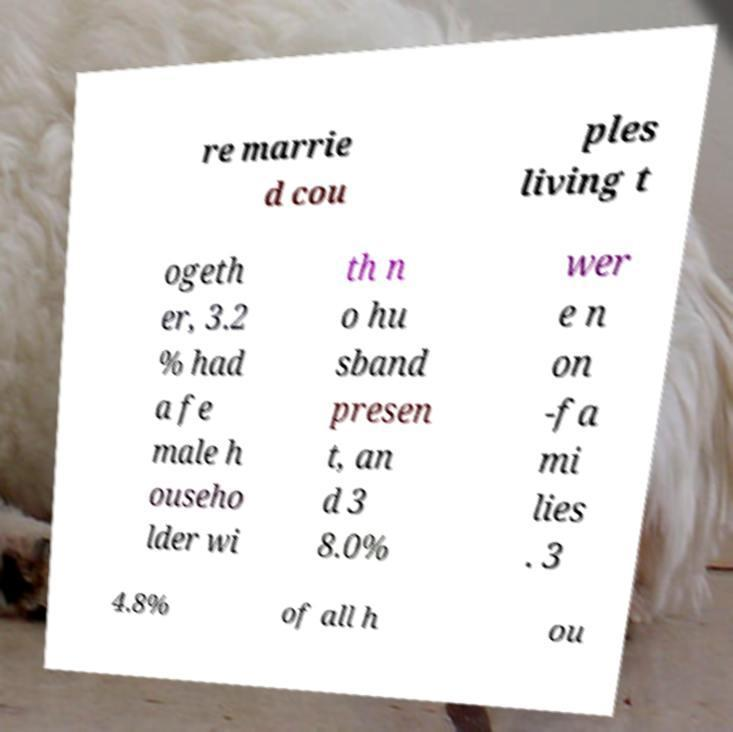For documentation purposes, I need the text within this image transcribed. Could you provide that? re marrie d cou ples living t ogeth er, 3.2 % had a fe male h ouseho lder wi th n o hu sband presen t, an d 3 8.0% wer e n on -fa mi lies . 3 4.8% of all h ou 